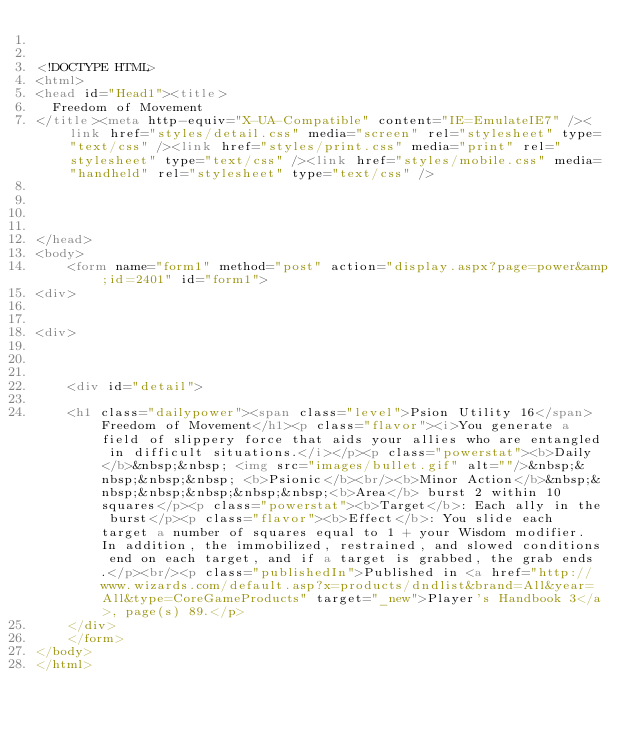Convert code to text. <code><loc_0><loc_0><loc_500><loc_500><_HTML_>

<!DOCTYPE HTML>
<html>
<head id="Head1"><title>
	Freedom of Movement
</title><meta http-equiv="X-UA-Compatible" content="IE=EmulateIE7" /><link href="styles/detail.css" media="screen" rel="stylesheet" type="text/css" /><link href="styles/print.css" media="print" rel="stylesheet" type="text/css" /><link href="styles/mobile.css" media="handheld" rel="stylesheet" type="text/css" />
    
    
    

</head>
<body>
    <form name="form1" method="post" action="display.aspx?page=power&amp;id=2401" id="form1">
<div>


<div>

	
	
    <div id="detail">
		
		<h1 class="dailypower"><span class="level">Psion Utility 16</span>Freedom of Movement</h1><p class="flavor"><i>You generate a field of slippery force that aids your allies who are entangled in difficult situations.</i></p><p class="powerstat"><b>Daily</b>&nbsp;&nbsp; <img src="images/bullet.gif" alt=""/>&nbsp;&nbsp;&nbsp;&nbsp; <b>Psionic</b><br/><b>Minor Action</b>&nbsp;&nbsp;&nbsp;&nbsp;&nbsp;&nbsp;<b>Area</b> burst 2 within 10 squares</p><p class="powerstat"><b>Target</b>: Each ally in the burst</p><p class="flavor"><b>Effect</b>: You slide each target a number of squares equal to 1 + your Wisdom modifier. In addition, the immobilized, restrained, and slowed conditions end on each target, and if a target is grabbed, the grab ends.</p><br/><p class="publishedIn">Published in <a href="http://www.wizards.com/default.asp?x=products/dndlist&brand=All&year=All&type=CoreGameProducts" target="_new">Player's Handbook 3</a>, page(s) 89.</p>
    </div>
    </form>
</body>
</html>


</code> 